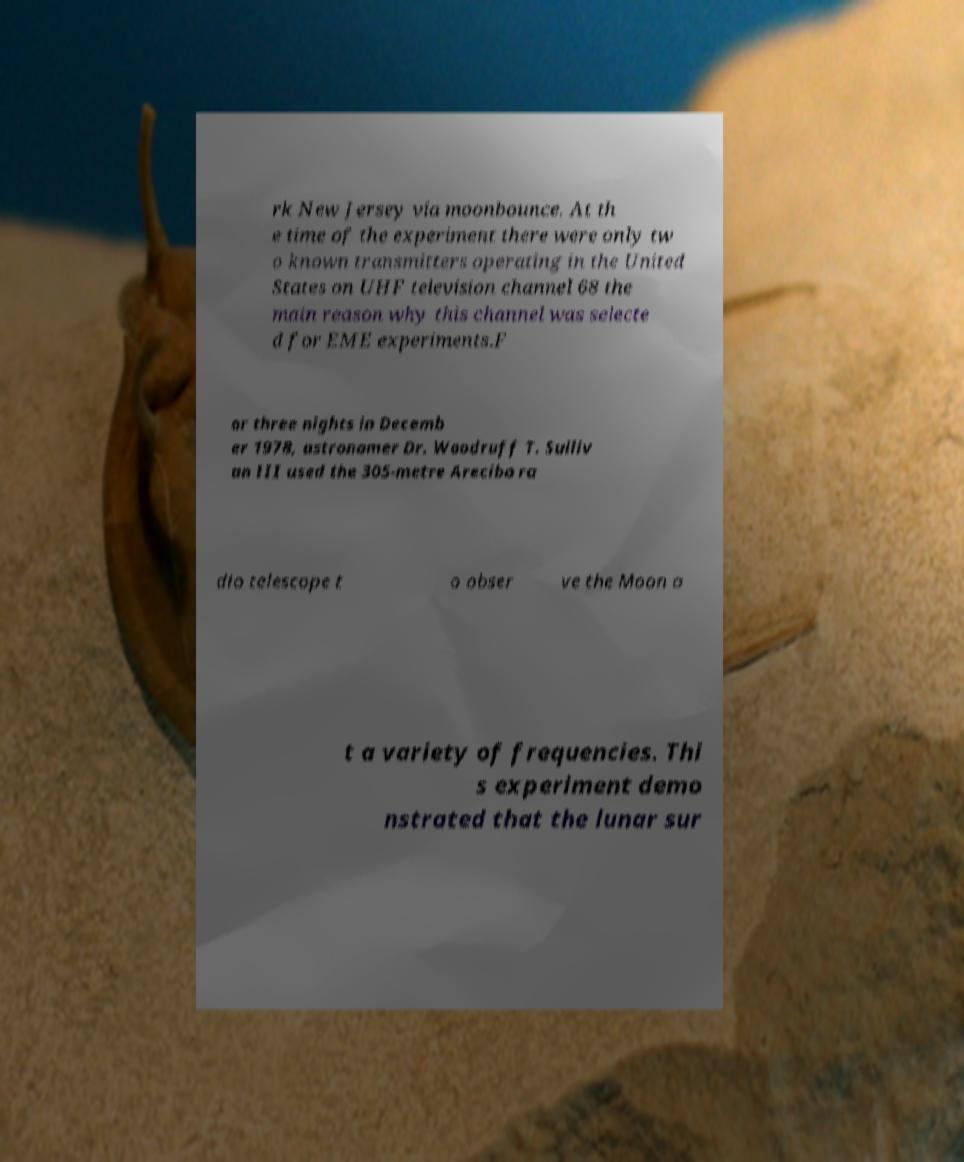Can you read and provide the text displayed in the image?This photo seems to have some interesting text. Can you extract and type it out for me? rk New Jersey via moonbounce. At th e time of the experiment there were only tw o known transmitters operating in the United States on UHF television channel 68 the main reason why this channel was selecte d for EME experiments.F or three nights in Decemb er 1978, astronomer Dr. Woodruff T. Sulliv an III used the 305-metre Arecibo ra dio telescope t o obser ve the Moon a t a variety of frequencies. Thi s experiment demo nstrated that the lunar sur 